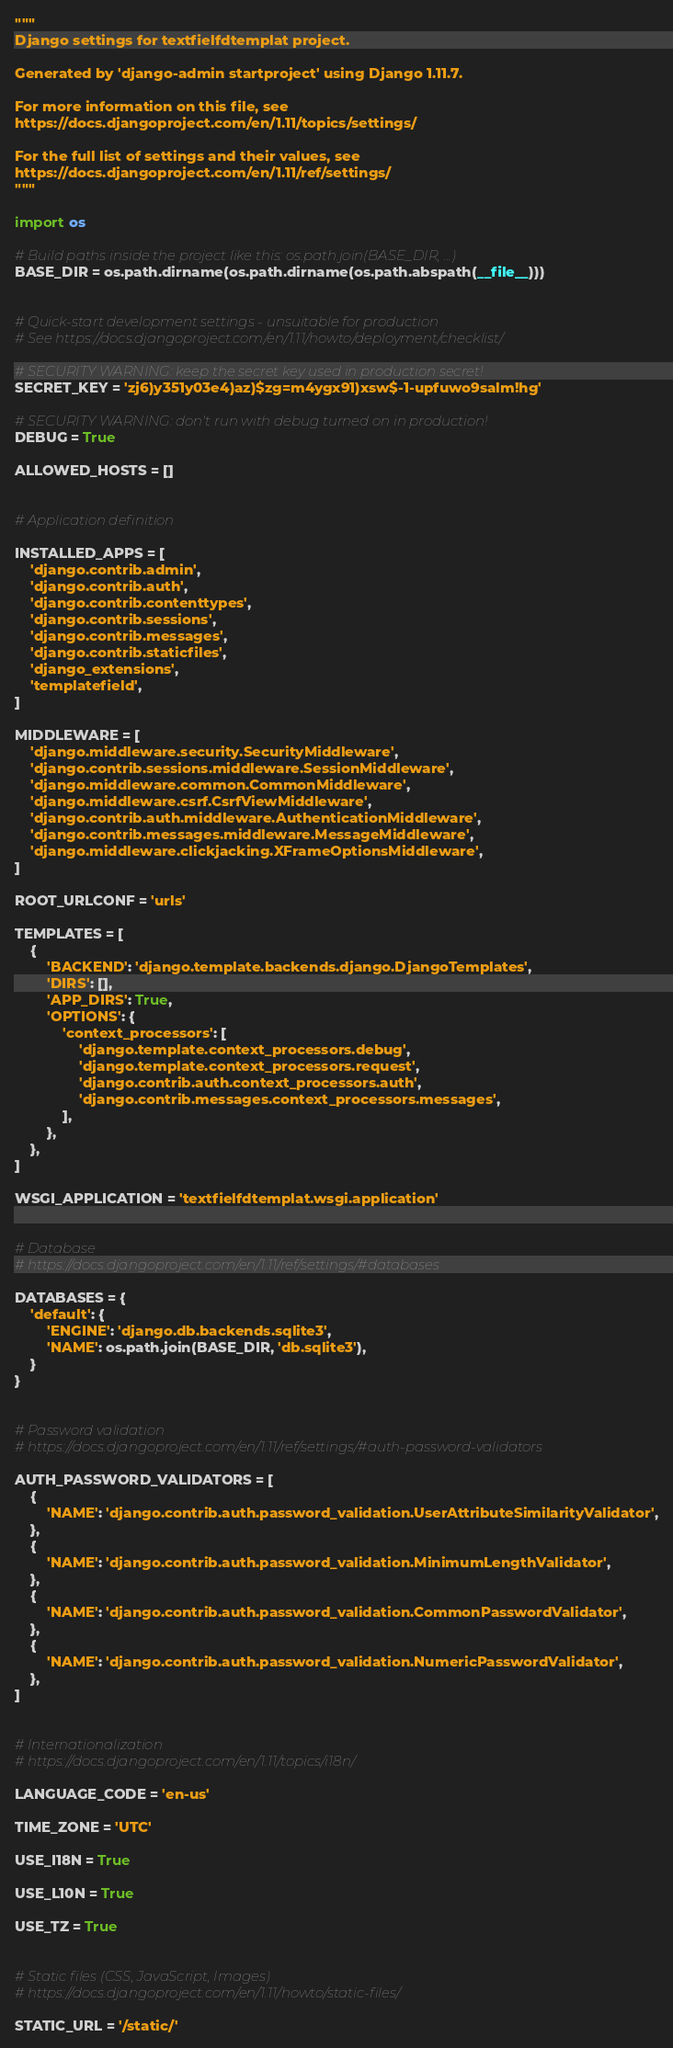<code> <loc_0><loc_0><loc_500><loc_500><_Python_>"""
Django settings for textfielfdtemplat project.

Generated by 'django-admin startproject' using Django 1.11.7.

For more information on this file, see
https://docs.djangoproject.com/en/1.11/topics/settings/

For the full list of settings and their values, see
https://docs.djangoproject.com/en/1.11/ref/settings/
"""

import os

# Build paths inside the project like this: os.path.join(BASE_DIR, ...)
BASE_DIR = os.path.dirname(os.path.dirname(os.path.abspath(__file__)))


# Quick-start development settings - unsuitable for production
# See https://docs.djangoproject.com/en/1.11/howto/deployment/checklist/

# SECURITY WARNING: keep the secret key used in production secret!
SECRET_KEY = 'zj6)y351y03e4)az)$zg=m4ygx91)xsw$-1-upfuwo9salm!hg'

# SECURITY WARNING: don't run with debug turned on in production!
DEBUG = True

ALLOWED_HOSTS = []


# Application definition

INSTALLED_APPS = [
    'django.contrib.admin',
    'django.contrib.auth',
    'django.contrib.contenttypes',
    'django.contrib.sessions',
    'django.contrib.messages',
    'django.contrib.staticfiles',
    'django_extensions',
    'templatefield',
]

MIDDLEWARE = [
    'django.middleware.security.SecurityMiddleware',
    'django.contrib.sessions.middleware.SessionMiddleware',
    'django.middleware.common.CommonMiddleware',
    'django.middleware.csrf.CsrfViewMiddleware',
    'django.contrib.auth.middleware.AuthenticationMiddleware',
    'django.contrib.messages.middleware.MessageMiddleware',
    'django.middleware.clickjacking.XFrameOptionsMiddleware',
]

ROOT_URLCONF = 'urls'

TEMPLATES = [
    {
        'BACKEND': 'django.template.backends.django.DjangoTemplates',
        'DIRS': [],
        'APP_DIRS': True,
        'OPTIONS': {
            'context_processors': [
                'django.template.context_processors.debug',
                'django.template.context_processors.request',
                'django.contrib.auth.context_processors.auth',
                'django.contrib.messages.context_processors.messages',
            ],
        },
    },
]

WSGI_APPLICATION = 'textfielfdtemplat.wsgi.application'


# Database
# https://docs.djangoproject.com/en/1.11/ref/settings/#databases

DATABASES = {
    'default': {
        'ENGINE': 'django.db.backends.sqlite3',
        'NAME': os.path.join(BASE_DIR, 'db.sqlite3'),
    }
}


# Password validation
# https://docs.djangoproject.com/en/1.11/ref/settings/#auth-password-validators

AUTH_PASSWORD_VALIDATORS = [
    {
        'NAME': 'django.contrib.auth.password_validation.UserAttributeSimilarityValidator',
    },
    {
        'NAME': 'django.contrib.auth.password_validation.MinimumLengthValidator',
    },
    {
        'NAME': 'django.contrib.auth.password_validation.CommonPasswordValidator',
    },
    {
        'NAME': 'django.contrib.auth.password_validation.NumericPasswordValidator',
    },
]


# Internationalization
# https://docs.djangoproject.com/en/1.11/topics/i18n/

LANGUAGE_CODE = 'en-us'

TIME_ZONE = 'UTC'

USE_I18N = True

USE_L10N = True

USE_TZ = True


# Static files (CSS, JavaScript, Images)
# https://docs.djangoproject.com/en/1.11/howto/static-files/

STATIC_URL = '/static/'
</code> 